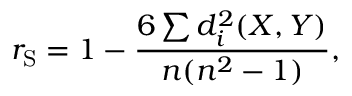<formula> <loc_0><loc_0><loc_500><loc_500>r _ { S } = 1 - { \frac { 6 \sum d _ { i } ^ { 2 } ( X , Y ) } { n ( n ^ { 2 } - 1 ) } } ,</formula> 